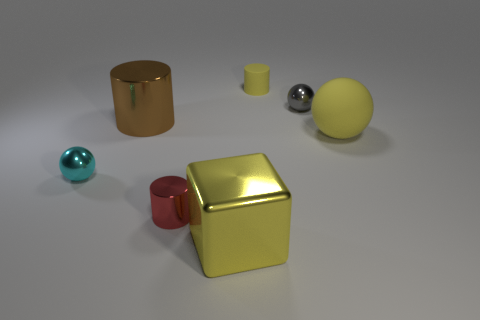There is a big metal thing that is the same color as the small rubber cylinder; what is its shape?
Make the answer very short. Cube. What is the size of the yellow thing that is right of the small metallic ball that is behind the big brown metal thing?
Make the answer very short. Large. There is a shiny block that is the same color as the big matte object; what is its size?
Provide a short and direct response. Large. What number of other things are the same size as the red cylinder?
Keep it short and to the point. 3. What number of large cylinders are there?
Keep it short and to the point. 1. Does the rubber sphere have the same size as the brown metallic cylinder?
Provide a short and direct response. Yes. How many other things are the same shape as the large brown metal object?
Your answer should be compact. 2. What is the material of the yellow object in front of the tiny ball in front of the large brown thing?
Provide a short and direct response. Metal. There is a big brown metallic cylinder; are there any red shiny cylinders in front of it?
Provide a short and direct response. Yes. Do the yellow cube and the rubber object in front of the small yellow matte cylinder have the same size?
Offer a very short reply. Yes. 